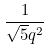Convert formula to latex. <formula><loc_0><loc_0><loc_500><loc_500>\frac { 1 } { \sqrt { 5 } q ^ { 2 } }</formula> 